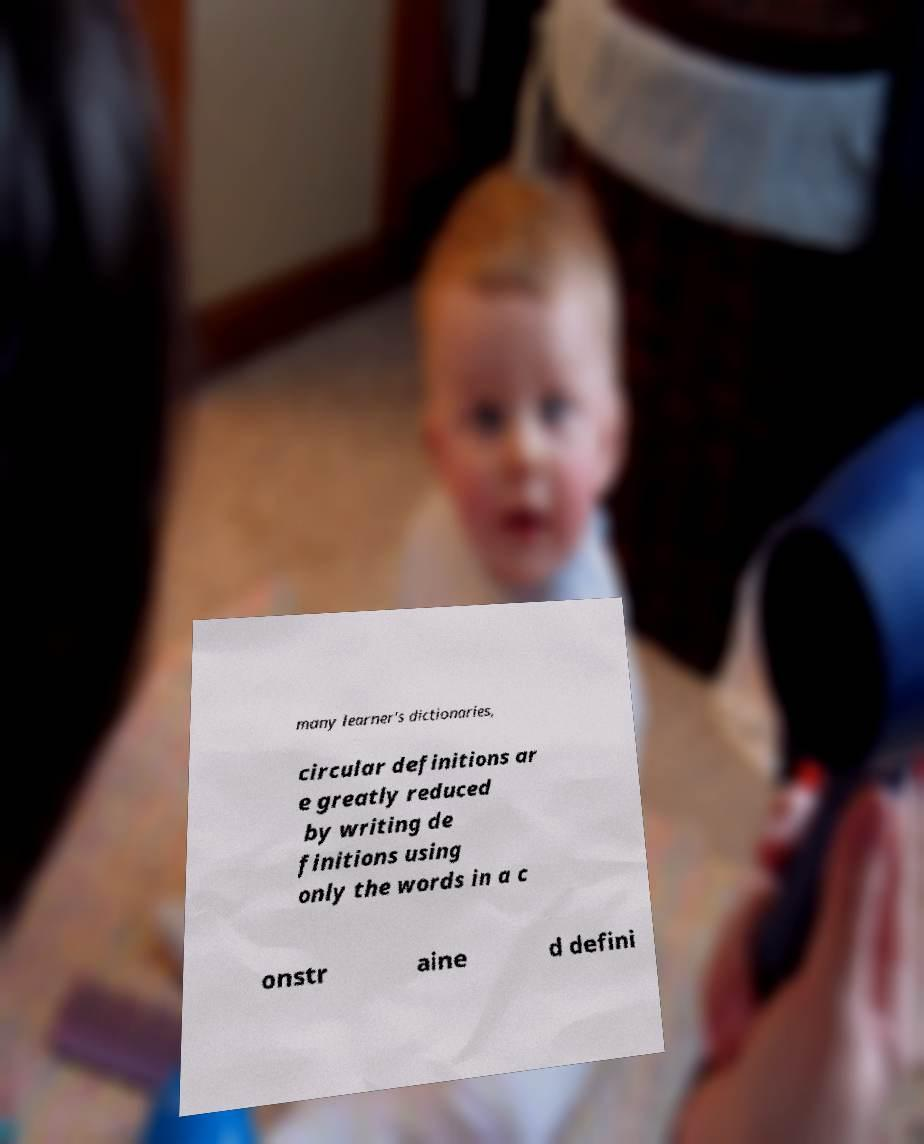Please identify and transcribe the text found in this image. many learner's dictionaries, circular definitions ar e greatly reduced by writing de finitions using only the words in a c onstr aine d defini 